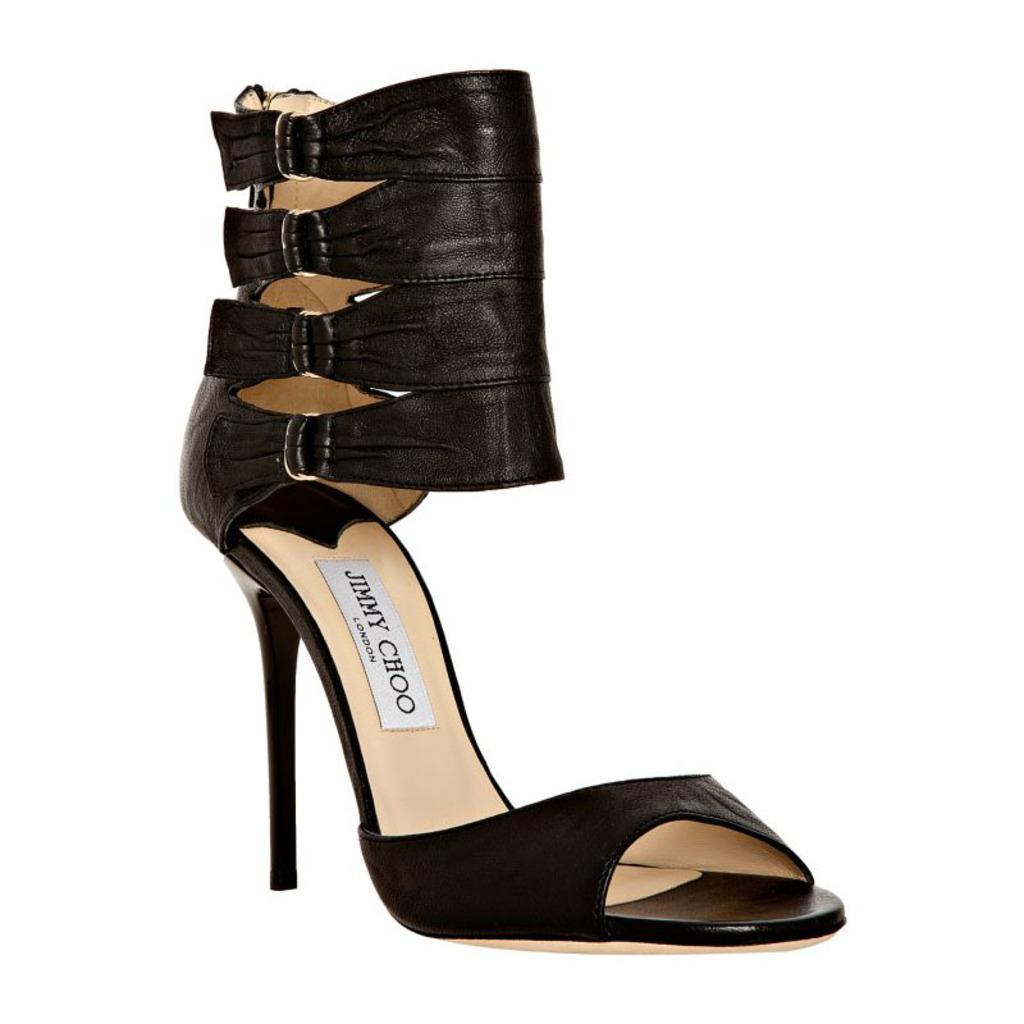What type of footwear is in the picture? There is a pair of women's footwear in the picture. What color is the footwear? The footwear is black in color. What can be seen in the background of the image? The background of the image is white. What type of cracker is visible on the footwear in the image? There is no cracker present on the footwear in the image. Can you describe the beetle that is crawling on the background of the image? There is no beetle present in the image; the background is white. 